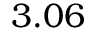Convert formula to latex. <formula><loc_0><loc_0><loc_500><loc_500>3 . 0 6</formula> 